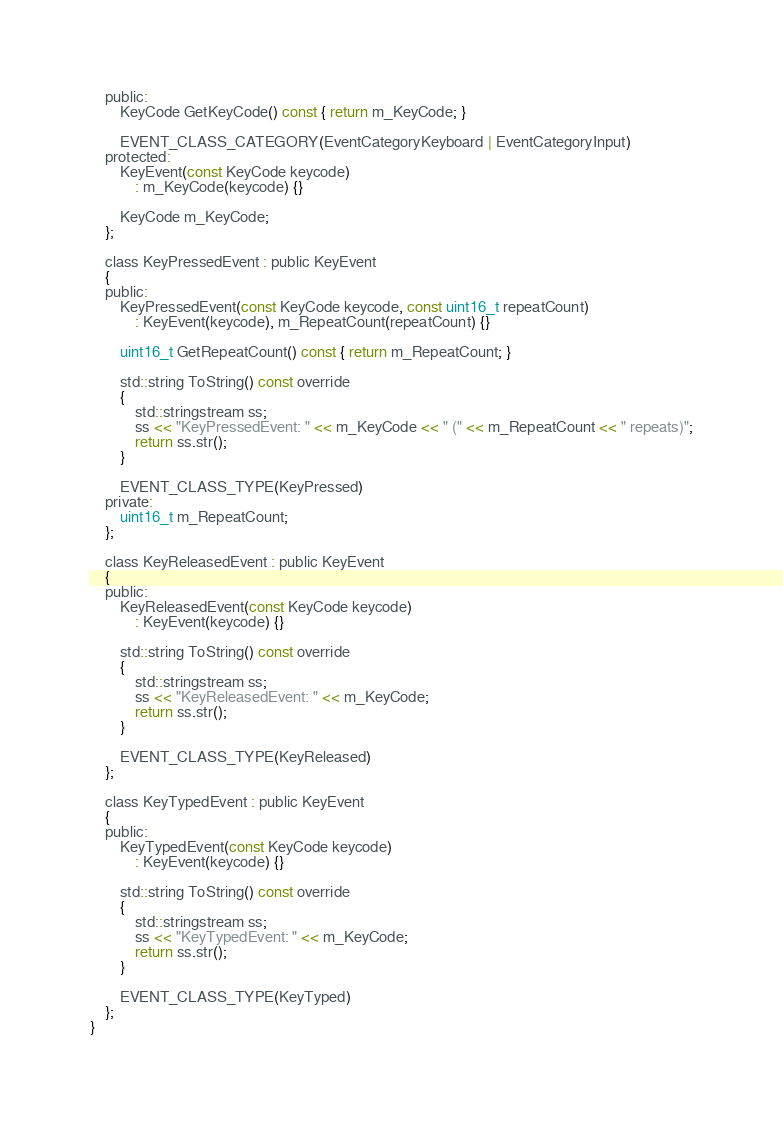Convert code to text. <code><loc_0><loc_0><loc_500><loc_500><_C_>	public:
		KeyCode GetKeyCode() const { return m_KeyCode; }

		EVENT_CLASS_CATEGORY(EventCategoryKeyboard | EventCategoryInput)
	protected:
		KeyEvent(const KeyCode keycode)
			: m_KeyCode(keycode) {}

		KeyCode m_KeyCode;
	};

	class KeyPressedEvent : public KeyEvent
	{
	public:
		KeyPressedEvent(const KeyCode keycode, const uint16_t repeatCount)
			: KeyEvent(keycode), m_RepeatCount(repeatCount) {}

		uint16_t GetRepeatCount() const { return m_RepeatCount; }

		std::string ToString() const override
		{
			std::stringstream ss;
			ss << "KeyPressedEvent: " << m_KeyCode << " (" << m_RepeatCount << " repeats)";
			return ss.str();
		}

		EVENT_CLASS_TYPE(KeyPressed)
	private:
		uint16_t m_RepeatCount;
	};

	class KeyReleasedEvent : public KeyEvent
	{
	public:
		KeyReleasedEvent(const KeyCode keycode)
			: KeyEvent(keycode) {}

		std::string ToString() const override
		{
			std::stringstream ss;
			ss << "KeyReleasedEvent: " << m_KeyCode;
			return ss.str();
		}

		EVENT_CLASS_TYPE(KeyReleased)
	};

	class KeyTypedEvent : public KeyEvent
	{
	public:
		KeyTypedEvent(const KeyCode keycode)
			: KeyEvent(keycode) {}

		std::string ToString() const override
		{
			std::stringstream ss;
			ss << "KeyTypedEvent: " << m_KeyCode;
			return ss.str();
		}

		EVENT_CLASS_TYPE(KeyTyped)
	};
}</code> 